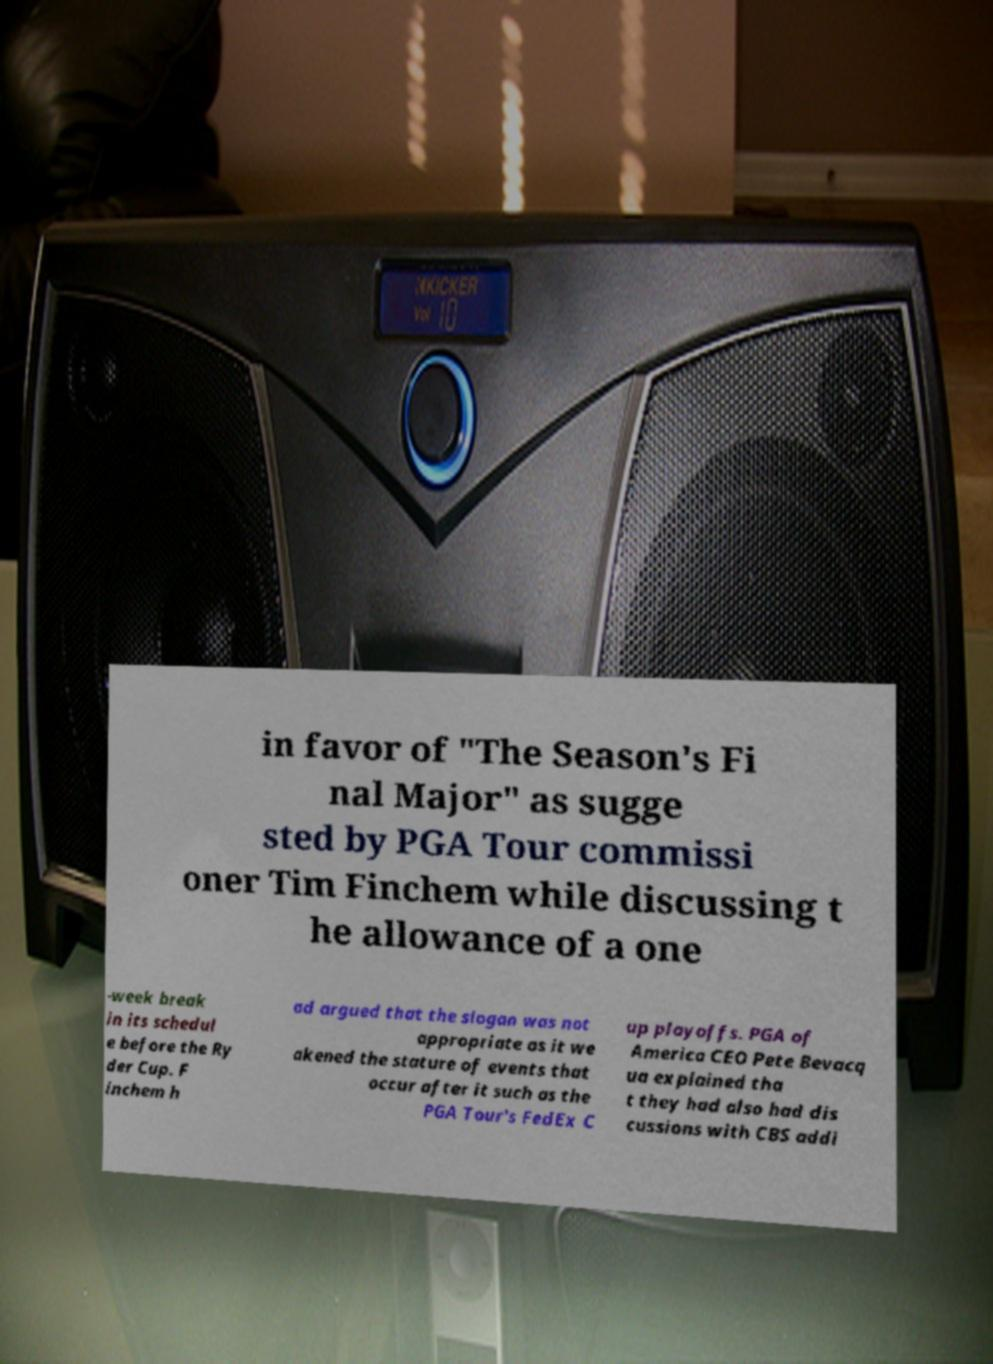Please identify and transcribe the text found in this image. in favor of "The Season's Fi nal Major" as sugge sted by PGA Tour commissi oner Tim Finchem while discussing t he allowance of a one -week break in its schedul e before the Ry der Cup. F inchem h ad argued that the slogan was not appropriate as it we akened the stature of events that occur after it such as the PGA Tour's FedEx C up playoffs. PGA of America CEO Pete Bevacq ua explained tha t they had also had dis cussions with CBS addi 